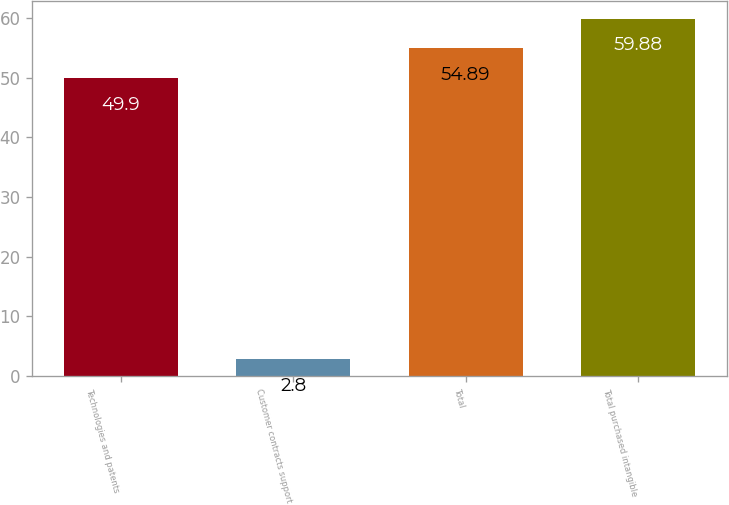Convert chart. <chart><loc_0><loc_0><loc_500><loc_500><bar_chart><fcel>Technologies and patents<fcel>Customer contracts support<fcel>Total<fcel>Total purchased intangible<nl><fcel>49.9<fcel>2.8<fcel>54.89<fcel>59.88<nl></chart> 